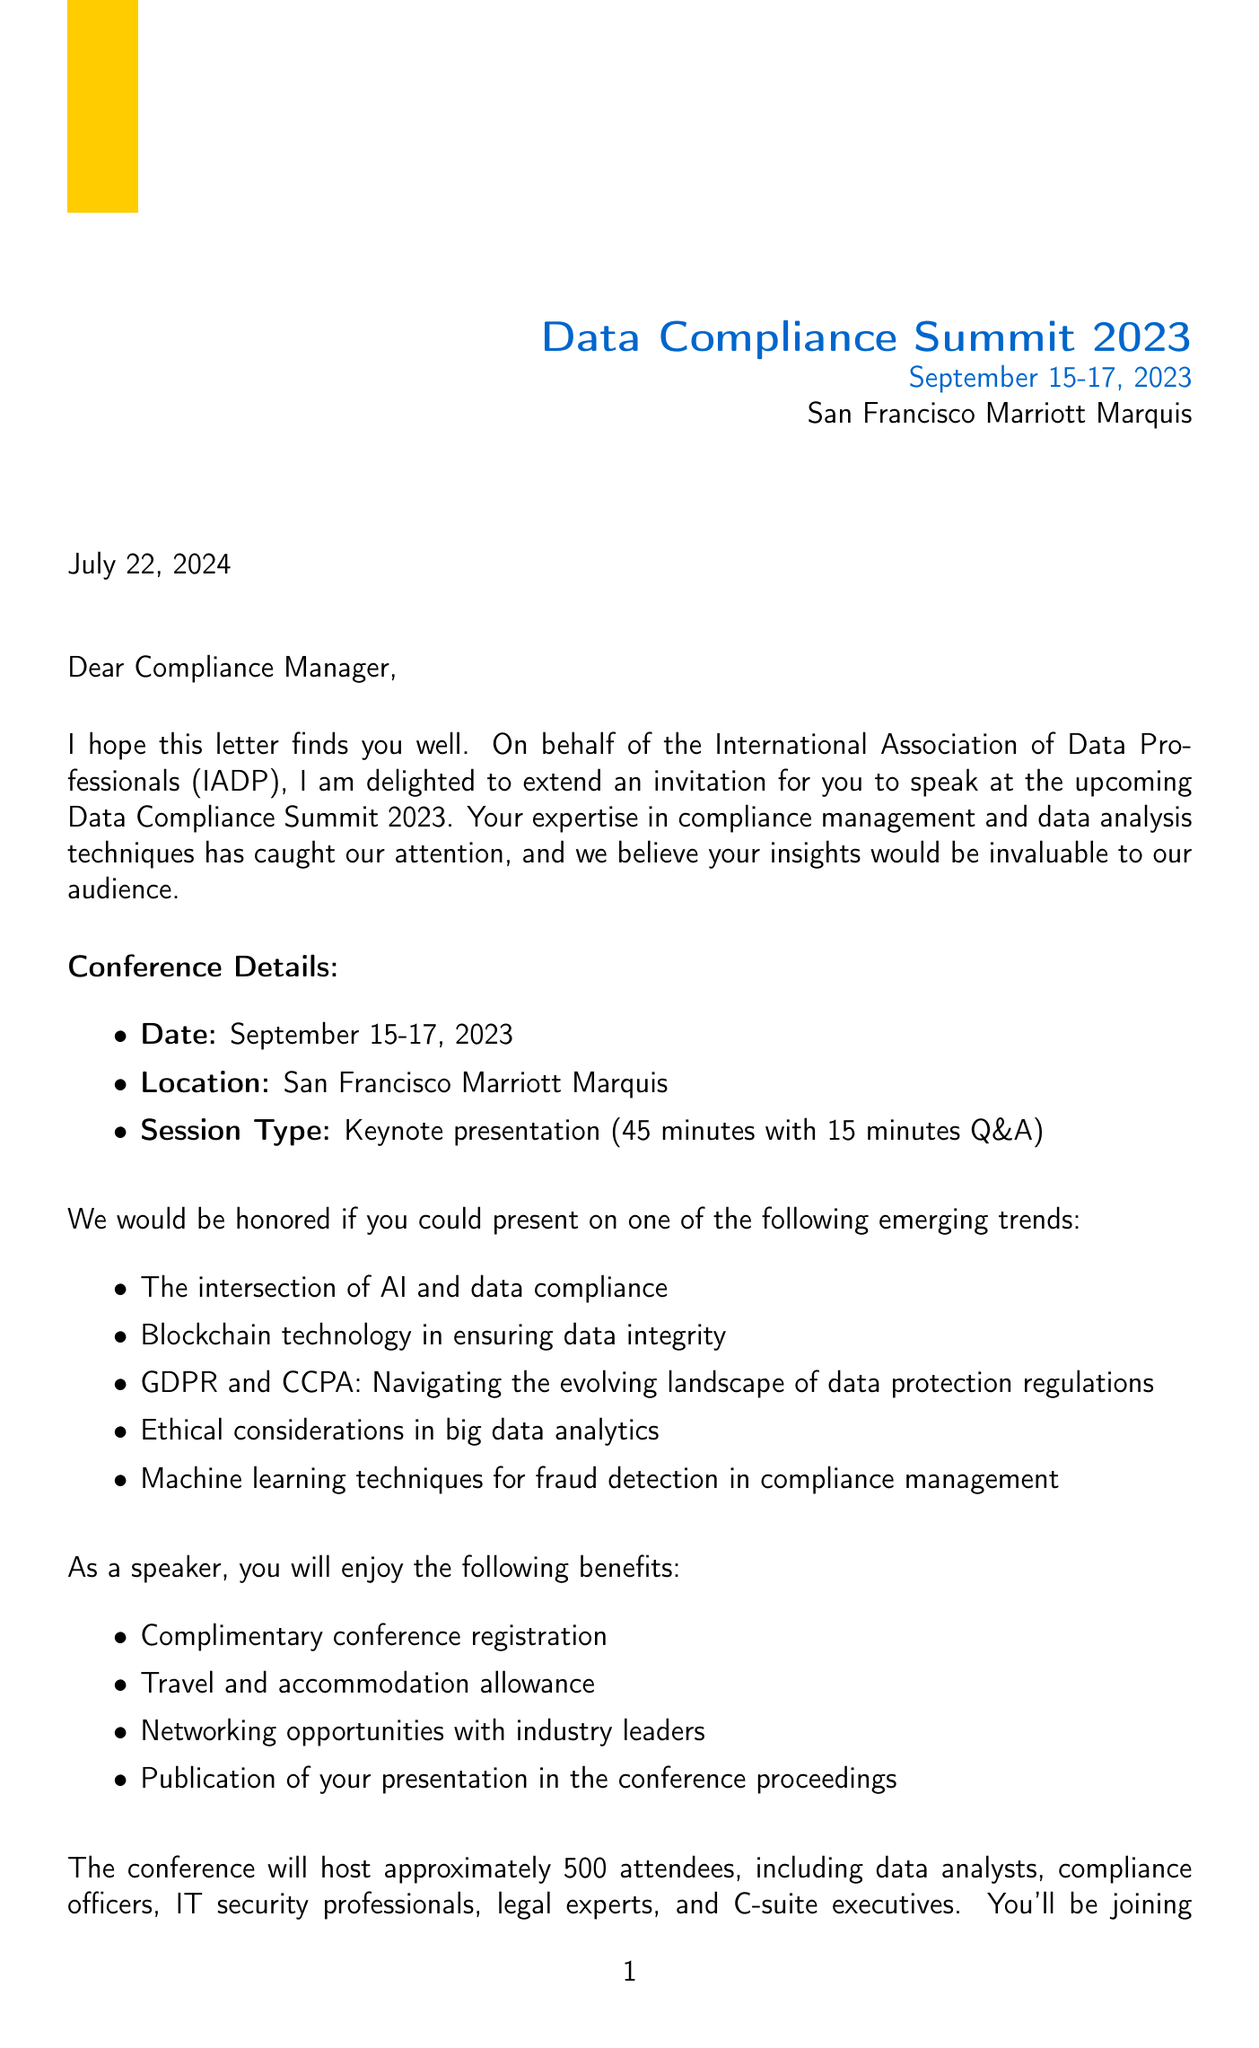What is the name of the conference? The document explicitly states the name of the conference as "Data Compliance Summit 2023."
Answer: Data Compliance Summit 2023 Who is the conference chair? The letter mentions Dr. Emily Chen as the individual who extends the invitation, indicating her role as the conference chair.
Answer: Dr. Emily Chen What are the conference dates? The document lists the conference dates as "September 15-17, 2023."
Answer: September 15-17, 2023 How long is the keynote presentation? The invitation specifies that the keynote presentation duration is "45 minutes with 15 minutes Q&A."
Answer: 45 minutes with 15 minutes Q&A What is one suggested topic for presentation? The document provides a list of suggested topics; one example is "The intersection of AI and data compliance."
Answer: The intersection of AI and data compliance What is the expected number of attendees? The document states that the conference will host approximately "500 attendees."
Answer: 500 What benefit is included for speakers? The letter outlines several benefits for speakers, one being "Complimentary conference registration."
Answer: Complimentary conference registration When is the deadline for speaker confirmation? The document clearly states the deadline for speaker confirmation is "July 15, 2023."
Answer: July 15, 2023 What type of event is mentioned in the letter? The document indicates that the event is a "Keynote presentation."
Answer: Keynote presentation 